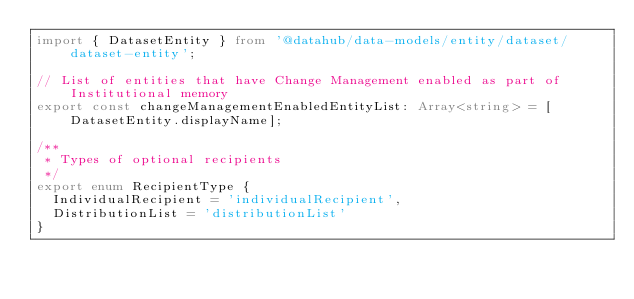<code> <loc_0><loc_0><loc_500><loc_500><_TypeScript_>import { DatasetEntity } from '@datahub/data-models/entity/dataset/dataset-entity';

// List of entities that have Change Management enabled as part of Institutional memory
export const changeManagementEnabledEntityList: Array<string> = [DatasetEntity.displayName];

/**
 * Types of optional recipients
 */
export enum RecipientType {
  IndividualRecipient = 'individualRecipient',
  DistributionList = 'distributionList'
}
</code> 